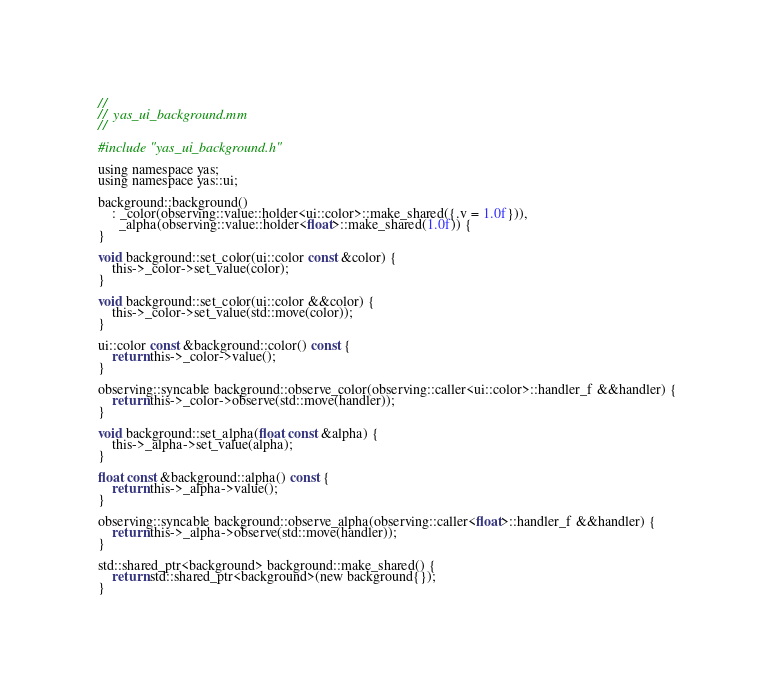Convert code to text. <code><loc_0><loc_0><loc_500><loc_500><_ObjectiveC_>//
//  yas_ui_background.mm
//

#include "yas_ui_background.h"

using namespace yas;
using namespace yas::ui;

background::background()
    : _color(observing::value::holder<ui::color>::make_shared({.v = 1.0f})),
      _alpha(observing::value::holder<float>::make_shared(1.0f)) {
}

void background::set_color(ui::color const &color) {
    this->_color->set_value(color);
}

void background::set_color(ui::color &&color) {
    this->_color->set_value(std::move(color));
}

ui::color const &background::color() const {
    return this->_color->value();
}

observing::syncable background::observe_color(observing::caller<ui::color>::handler_f &&handler) {
    return this->_color->observe(std::move(handler));
}

void background::set_alpha(float const &alpha) {
    this->_alpha->set_value(alpha);
}

float const &background::alpha() const {
    return this->_alpha->value();
}

observing::syncable background::observe_alpha(observing::caller<float>::handler_f &&handler) {
    return this->_alpha->observe(std::move(handler));
}

std::shared_ptr<background> background::make_shared() {
    return std::shared_ptr<background>(new background{});
}
</code> 